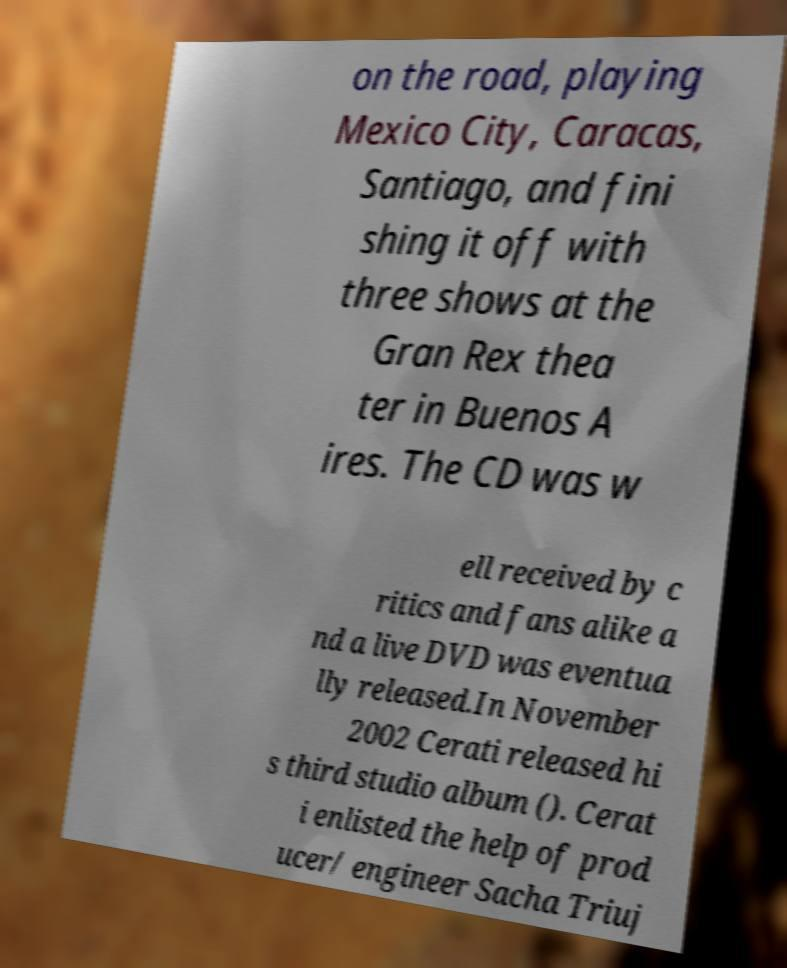Could you assist in decoding the text presented in this image and type it out clearly? on the road, playing Mexico City, Caracas, Santiago, and fini shing it off with three shows at the Gran Rex thea ter in Buenos A ires. The CD was w ell received by c ritics and fans alike a nd a live DVD was eventua lly released.In November 2002 Cerati released hi s third studio album (). Cerat i enlisted the help of prod ucer/ engineer Sacha Triuj 